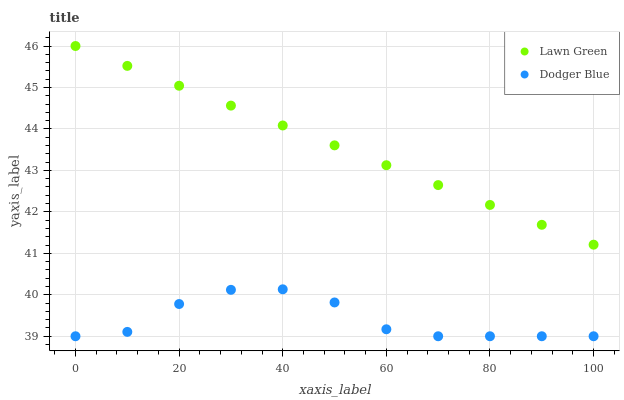Does Dodger Blue have the minimum area under the curve?
Answer yes or no. Yes. Does Lawn Green have the maximum area under the curve?
Answer yes or no. Yes. Does Dodger Blue have the maximum area under the curve?
Answer yes or no. No. Is Lawn Green the smoothest?
Answer yes or no. Yes. Is Dodger Blue the roughest?
Answer yes or no. Yes. Is Dodger Blue the smoothest?
Answer yes or no. No. Does Dodger Blue have the lowest value?
Answer yes or no. Yes. Does Lawn Green have the highest value?
Answer yes or no. Yes. Does Dodger Blue have the highest value?
Answer yes or no. No. Is Dodger Blue less than Lawn Green?
Answer yes or no. Yes. Is Lawn Green greater than Dodger Blue?
Answer yes or no. Yes. Does Dodger Blue intersect Lawn Green?
Answer yes or no. No. 